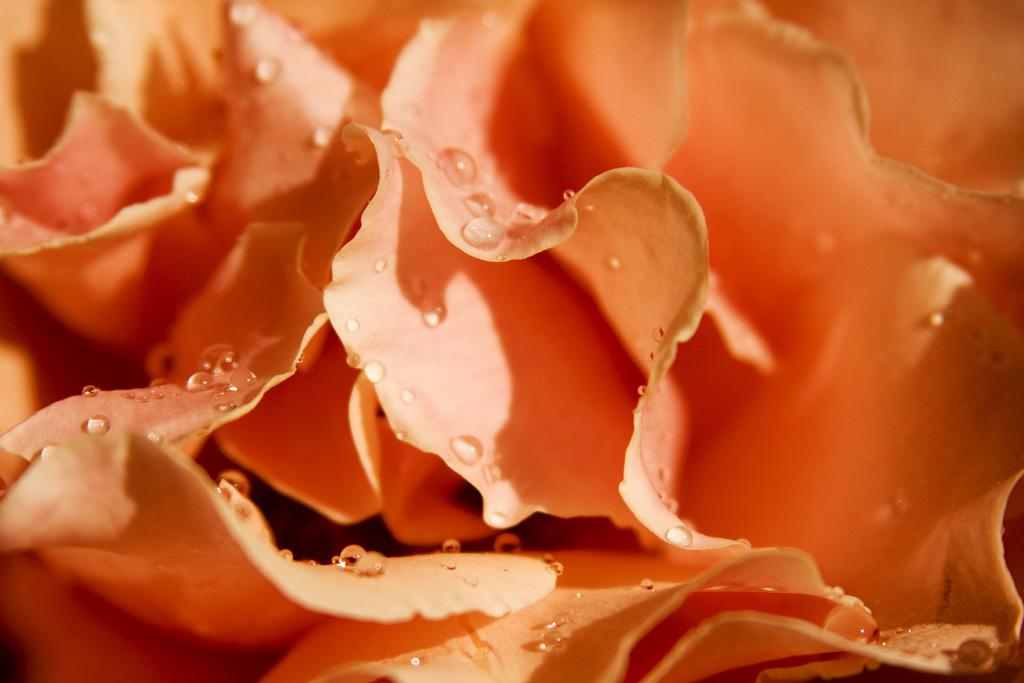What type of plants can be seen in the image? There are flowers in the image. What is the condition of the flowers in the image? There are water drops on the flowers. What type of agreement is being signed by the flowers in the image? There is no agreement being signed in the image, as it features flowers with water drops on them. How many cherries can be seen on the flowers in the image? There are no cherries present in the image; it only features flowers with water drops. 